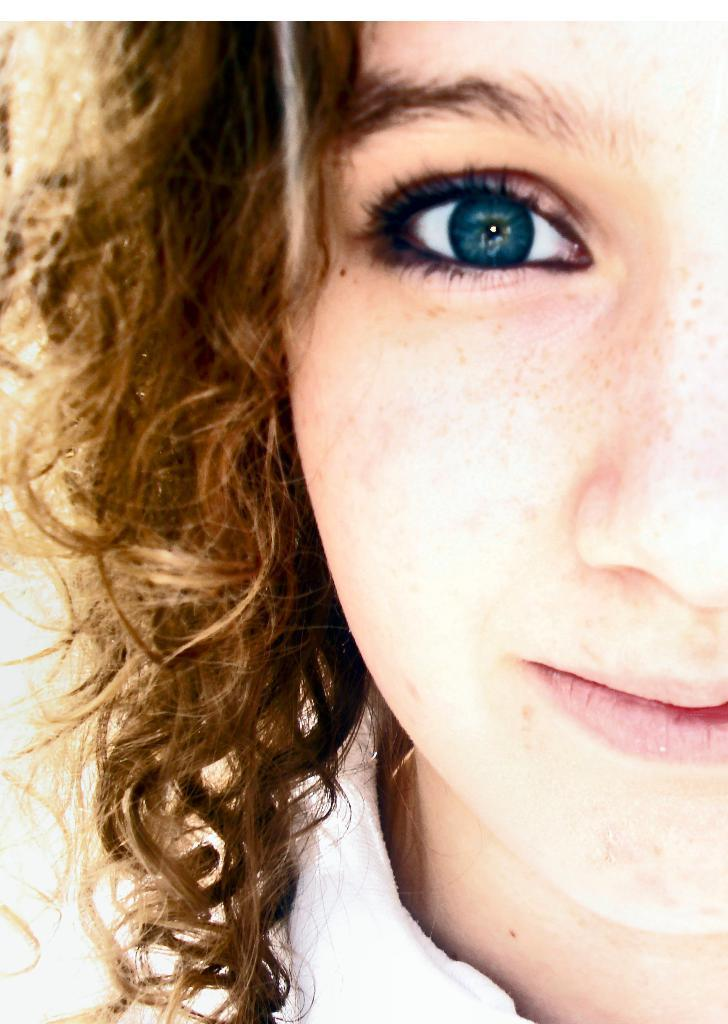What is the main subject of the image? There is a woman's face in the image. What type of game is being played in the image? There is no game present in the image; it features a woman's face. What kind of yam is being used as a prop in the image? There is no yam present in the image; it features a woman's face. 